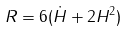<formula> <loc_0><loc_0><loc_500><loc_500>R = 6 ( \dot { H } + 2 H ^ { 2 } )</formula> 